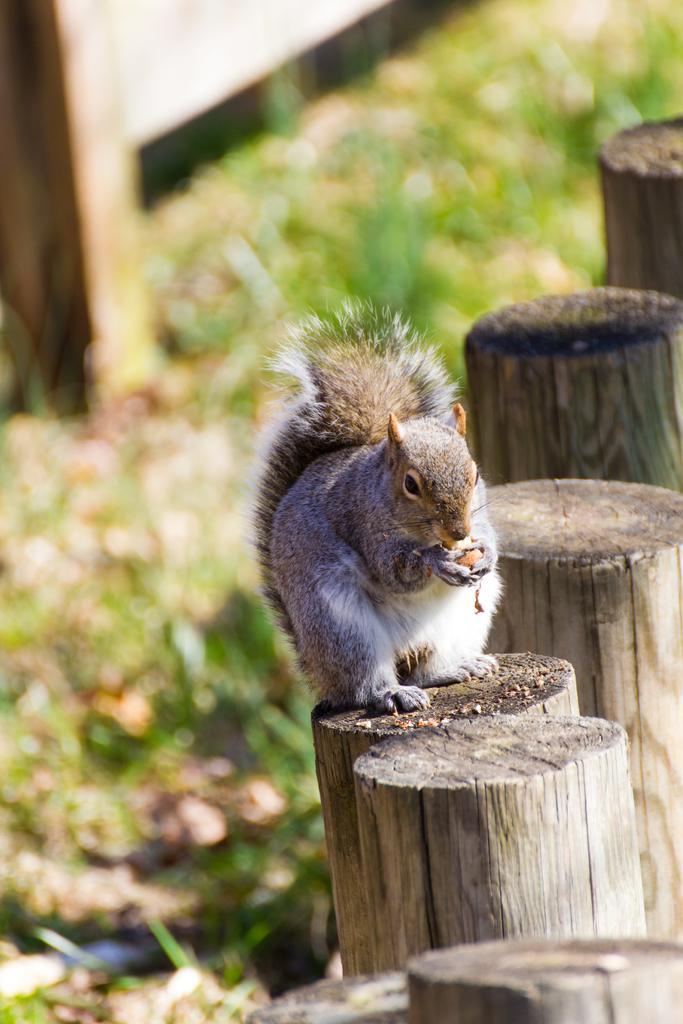In one or two sentences, can you explain what this image depicts? This image consists of a squirrel is sitting on a wooden stick. At the bottom, there is green grass. In the background, there is a fencing. 